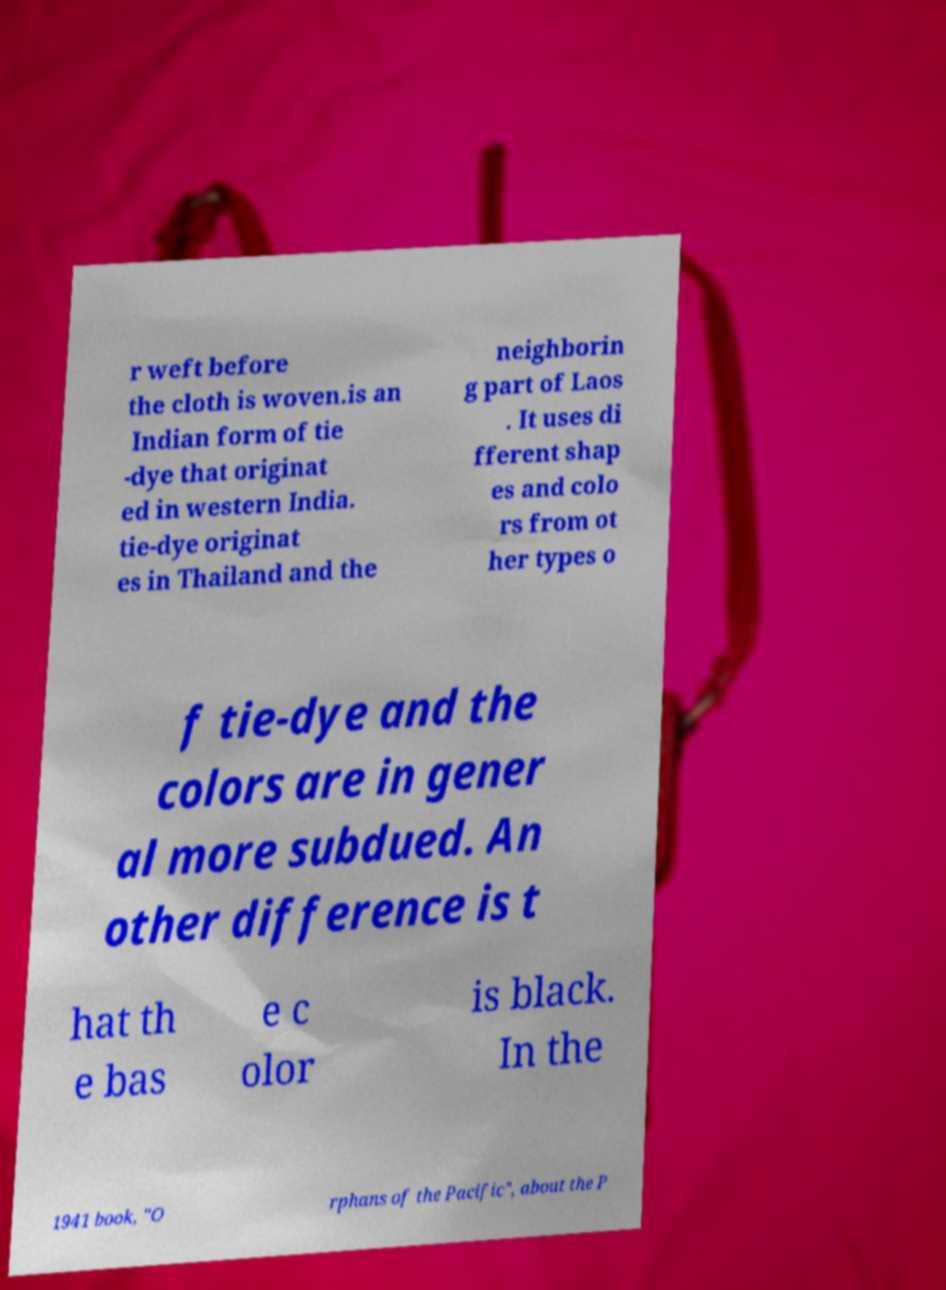I need the written content from this picture converted into text. Can you do that? r weft before the cloth is woven.is an Indian form of tie -dye that originat ed in western India. tie-dye originat es in Thailand and the neighborin g part of Laos . It uses di fferent shap es and colo rs from ot her types o f tie-dye and the colors are in gener al more subdued. An other difference is t hat th e bas e c olor is black. In the 1941 book, "O rphans of the Pacific", about the P 